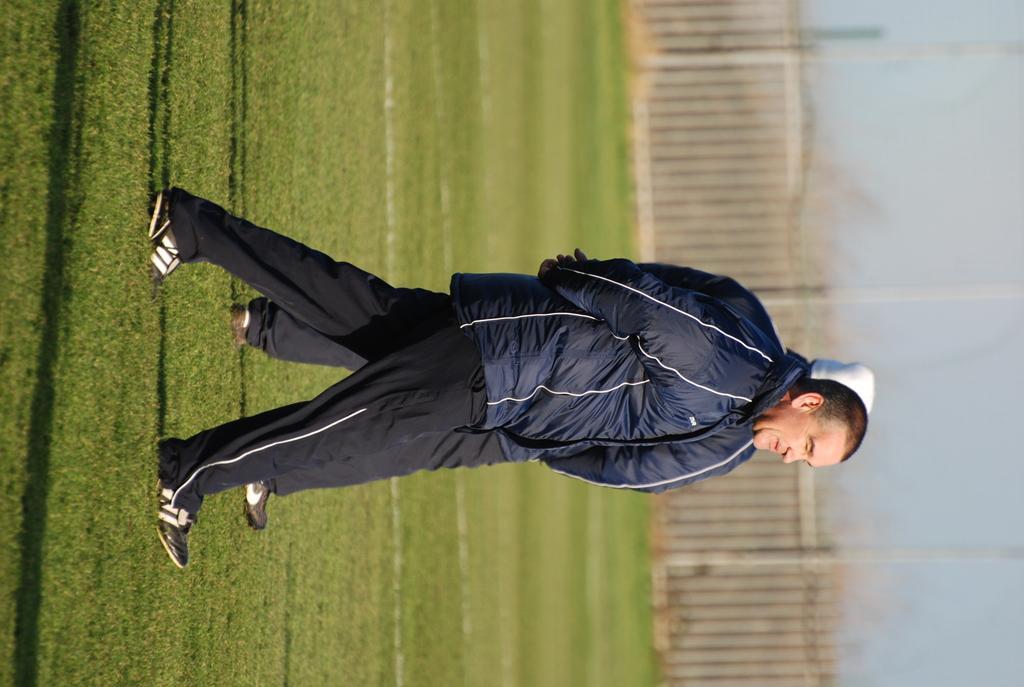In one or two sentences, can you explain what this image depicts? This image is taken outdoors. On the right side of the image there is a sky. There are a few trees and there is a fencing with wooden blocks. At the bottom of the image there is a ground with grass on it. In the middle of the image two men are walking on the ground. 